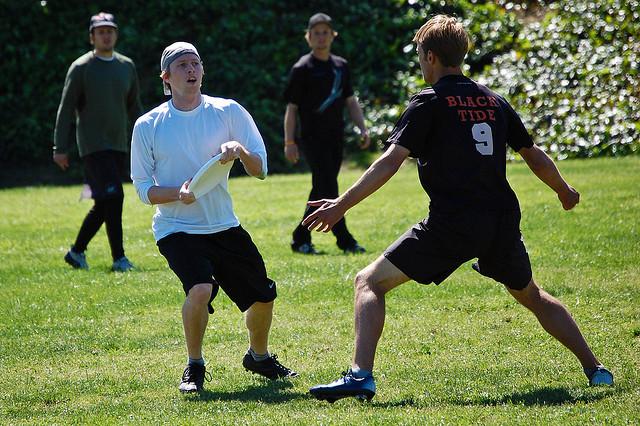What color is the grass?
Answer briefly. Green. Who has the frisbee?
Write a very short answer. Man in white. Is number 9 blocking?
Answer briefly. Yes. What letter is shown on the boy in black?
Write a very short answer. B. Would you see the man on the right is playing aggressively?
Short answer required. Yes. Does the man in the white shirt look aggressive?
Answer briefly. Yes. Are the men playing rugby or football?
Short answer required. Neither. Are all of these people male?
Concise answer only. Yes. Does anyone wear long pants?
Short answer required. Yes. Is the man falling?
Concise answer only. No. Are they all men?
Answer briefly. Yes. What sport is being played?
Concise answer only. Frisbee. 